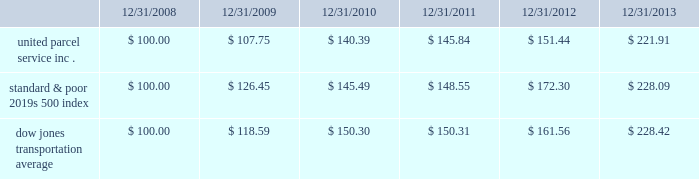Shareowner return performance graph the following performance graph and related information shall not be deemed 201csoliciting material 201d or to be 201cfiled 201d with the sec , nor shall such information be incorporated by reference into any future filing under the securities act of 1933 or securities exchange act of 1934 , each as amended , except to the extent that the company specifically incorporates such information by reference into such filing .
The following graph shows a five year comparison of cumulative total shareowners 2019 returns for our class b common stock , the standard & poor 2019s 500 index , and the dow jones transportation average .
The comparison of the total cumulative return on investment , which is the change in the quarterly stock price plus reinvested dividends for each of the quarterly periods , assumes that $ 100 was invested on december 31 , 2008 in the standard & poor 2019s 500 index , the dow jones transportation average , and our class b common stock. .

What was the difference in percentage total cumulative return on investment for united parcel service inc . compared to the dow jones transportation average for the five years ended 12/31/2013? 
Computations: (((221.91 - 100) / 100) - ((228.42 - 100) / 100))
Answer: -0.0651. 